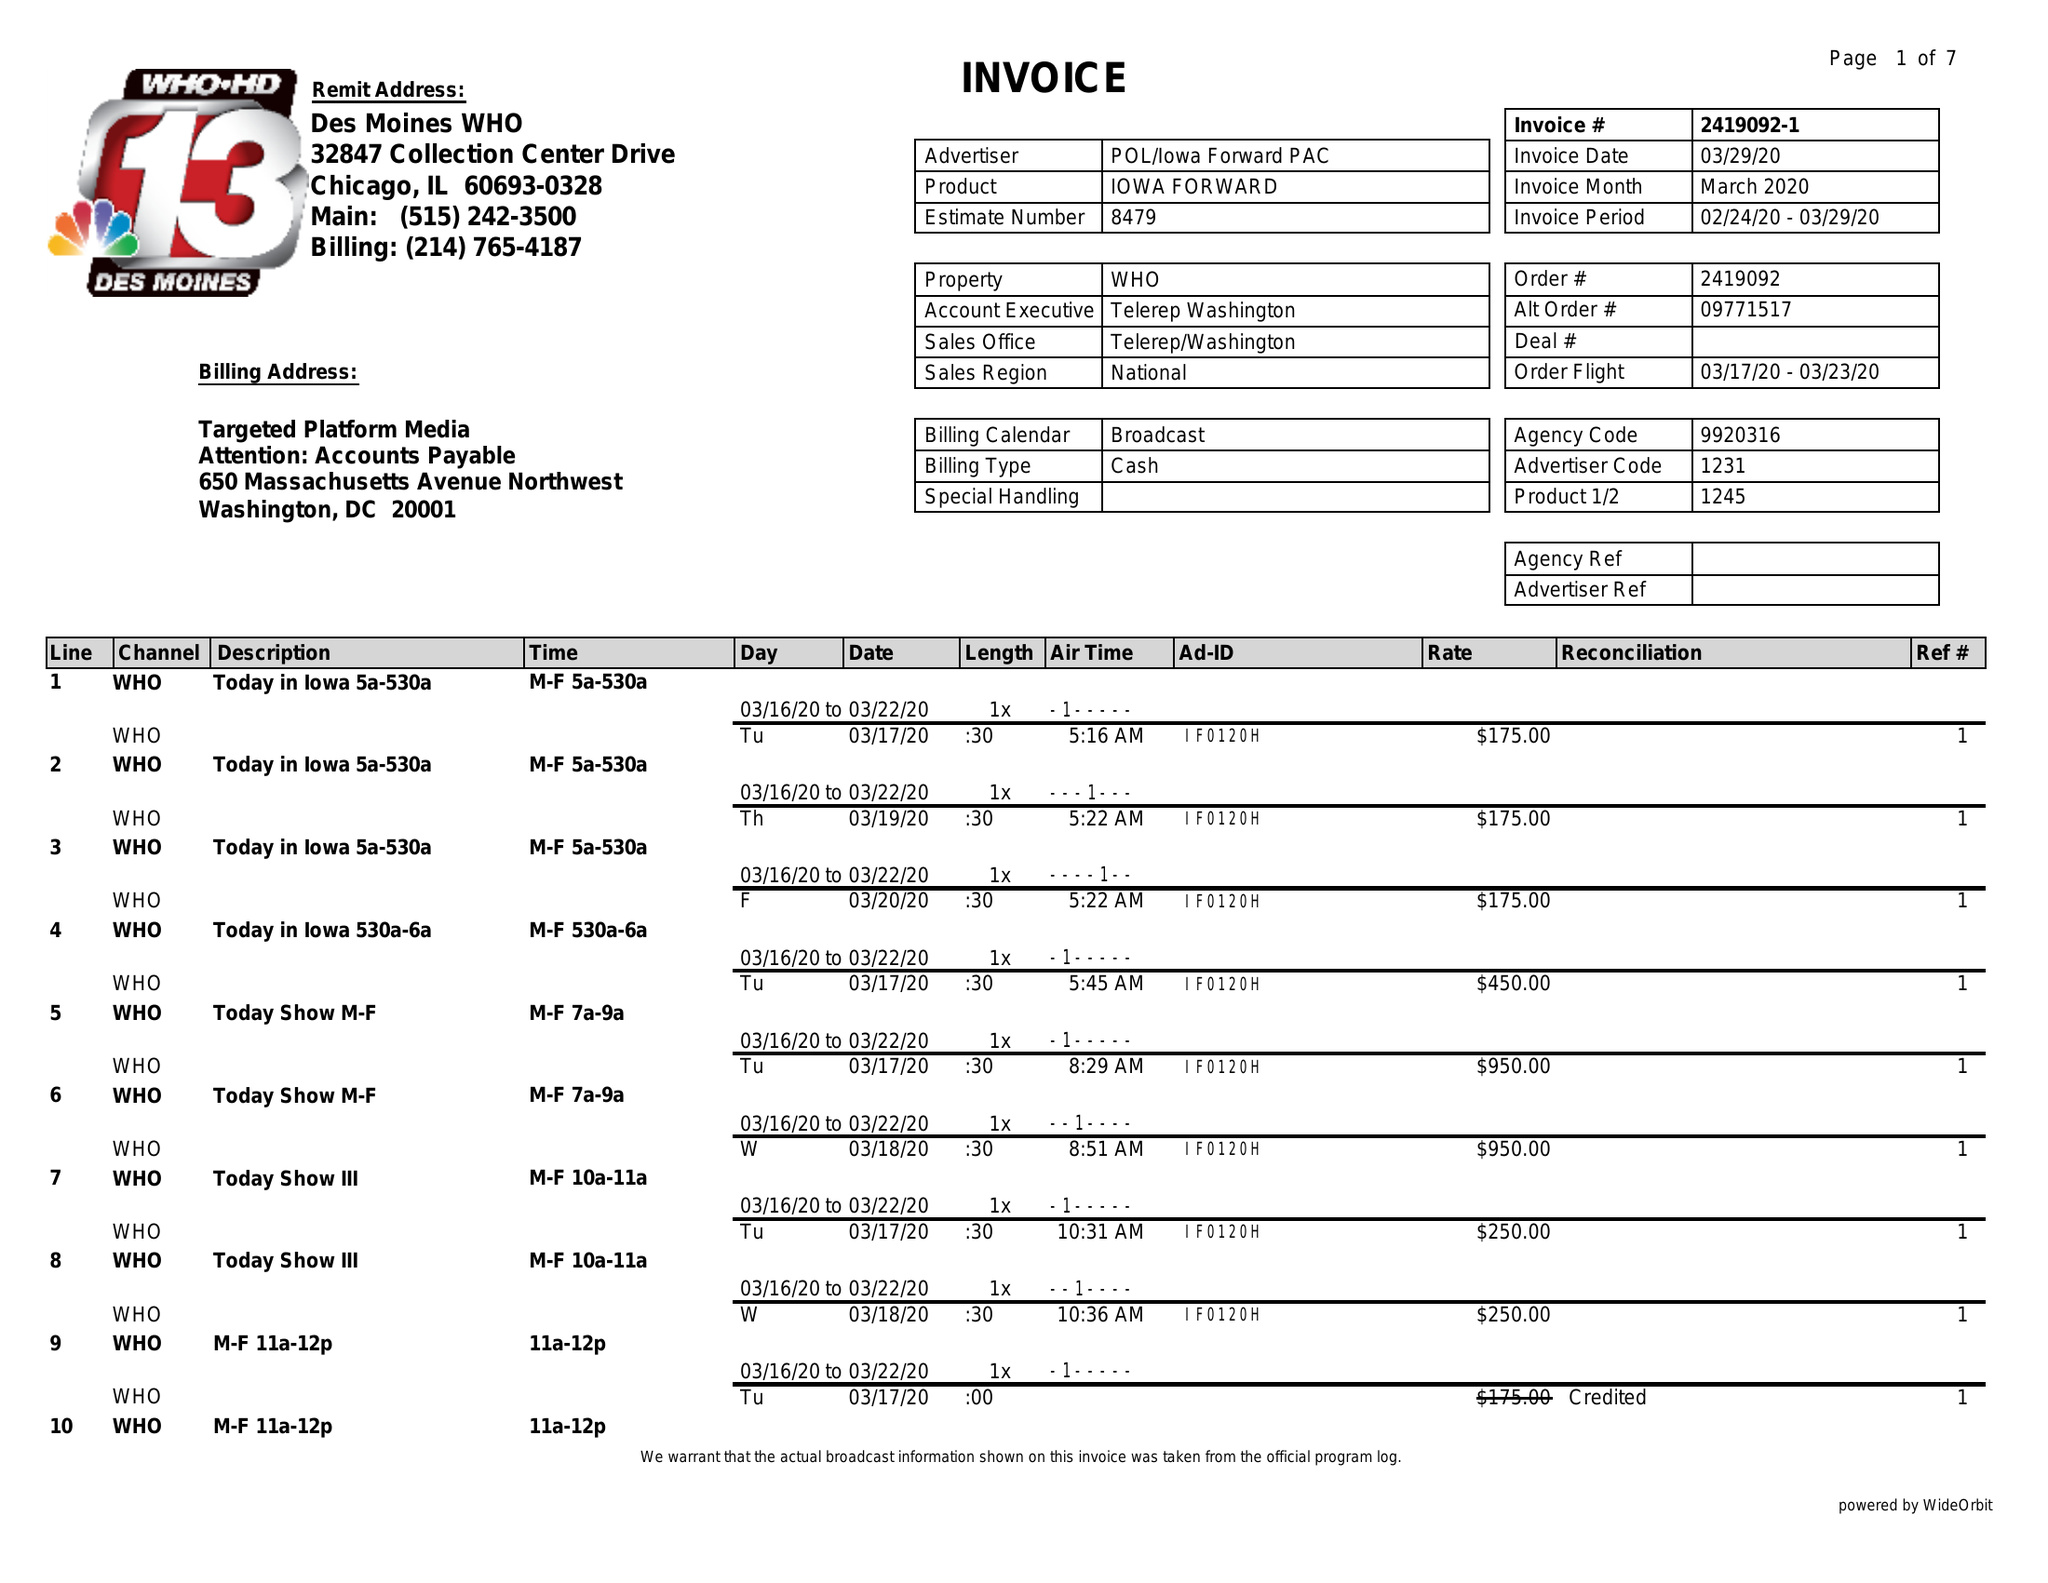What is the value for the advertiser?
Answer the question using a single word or phrase. POL/IOWAFORWARDPAC 